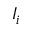<formula> <loc_0><loc_0><loc_500><loc_500>I _ { i }</formula> 